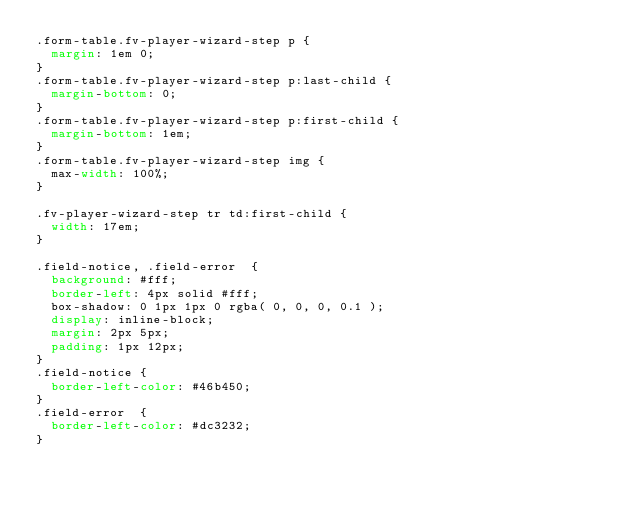<code> <loc_0><loc_0><loc_500><loc_500><_CSS_>.form-table.fv-player-wizard-step p {
  margin: 1em 0;
}
.form-table.fv-player-wizard-step p:last-child {
  margin-bottom: 0;
}
.form-table.fv-player-wizard-step p:first-child {
  margin-bottom: 1em;
}
.form-table.fv-player-wizard-step img {
  max-width: 100%;
}

.fv-player-wizard-step tr td:first-child {
  width: 17em;
}

.field-notice, .field-error  {
  background: #fff;
  border-left: 4px solid #fff;
  box-shadow: 0 1px 1px 0 rgba( 0, 0, 0, 0.1 );
  display: inline-block;
  margin: 2px 5px;
  padding: 1px 12px;
}
.field-notice {
  border-left-color: #46b450;
}
.field-error  {
  border-left-color: #dc3232;
}</code> 